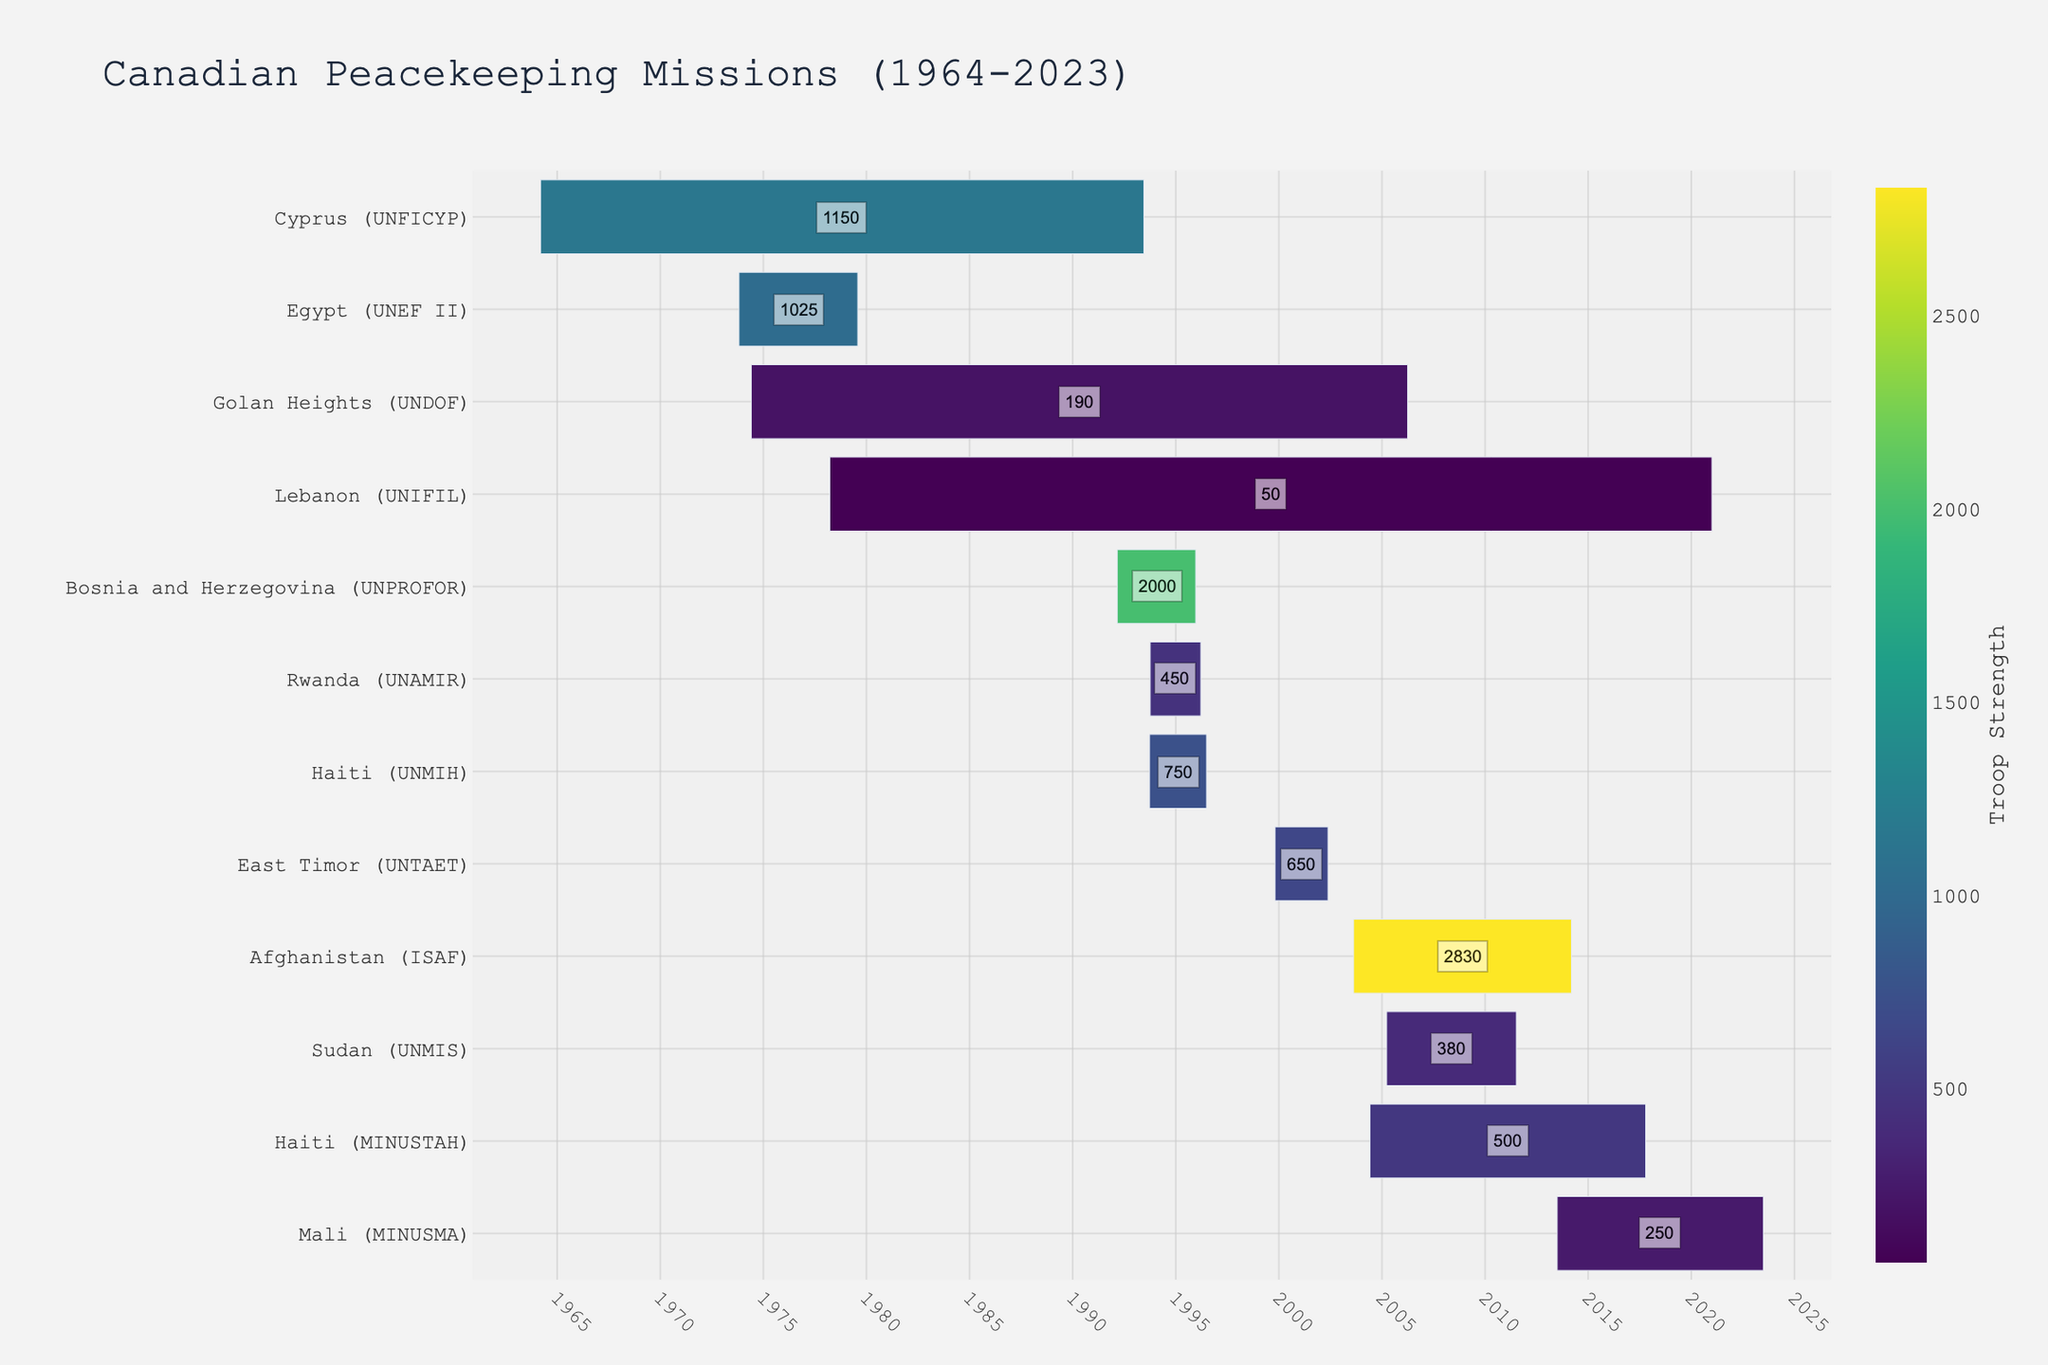What's the title of the figure? The title is displayed at the top of the figure usually in larger or bold font. It summarizes the content of the figure.
Answer: Canadian Peacekeeping Missions (1964-2023) Which mission had the highest troop strength? By looking at the color intensity and the troop strength annotations, we identify the mission with the highest troop strength.
Answer: Afghanistan (ISAF) What is the duration of Canada's mission in Cyprus? Locate "Cyprus (UNFICYP)" on the chart and calculate the years between the Start Date and End Date.
Answer: 29.25 years How many missions lasted more than 10 years? Count the number of mission bars where the time span exceeds 10 years.
Answer: 6 missions Which mission had the lowest troop strength? By examining the color scale and troop strength annotations, we can identify the mission with the least number of troops.
Answer: Lebanon (UNIFIL) What are the start and end dates for the Rwanda (UNAMIR) mission? Find "Rwanda (UNAMIR)" on the y-axis and note the x-axis positions for the start and end points of the bar.
Answer: Start: 1993-10-05, End: 1996-03-19 Which missions were active during 2005? Identify the mission bars that overlap with the year 2005 on the x-axis.
Answer: Golan Heights (UNDOF), Sudan (UNMIS), Haiti (MINUSTAH) Compare the troop strengths of the Haiti (UNMIH) mission and the Mali (MINUSMA) mission. Which had more troops? Look at the troop strength annotations next to each mission.
Answer: Haiti (UNMIH) Calculate the total duration of the Bosnia and Herzegovina (UNPROFOR) mission in years and months. Subtract the Start Date from the End Date, calculate the total days, convert it into years and months.
Answer: 3 years and 9 months 